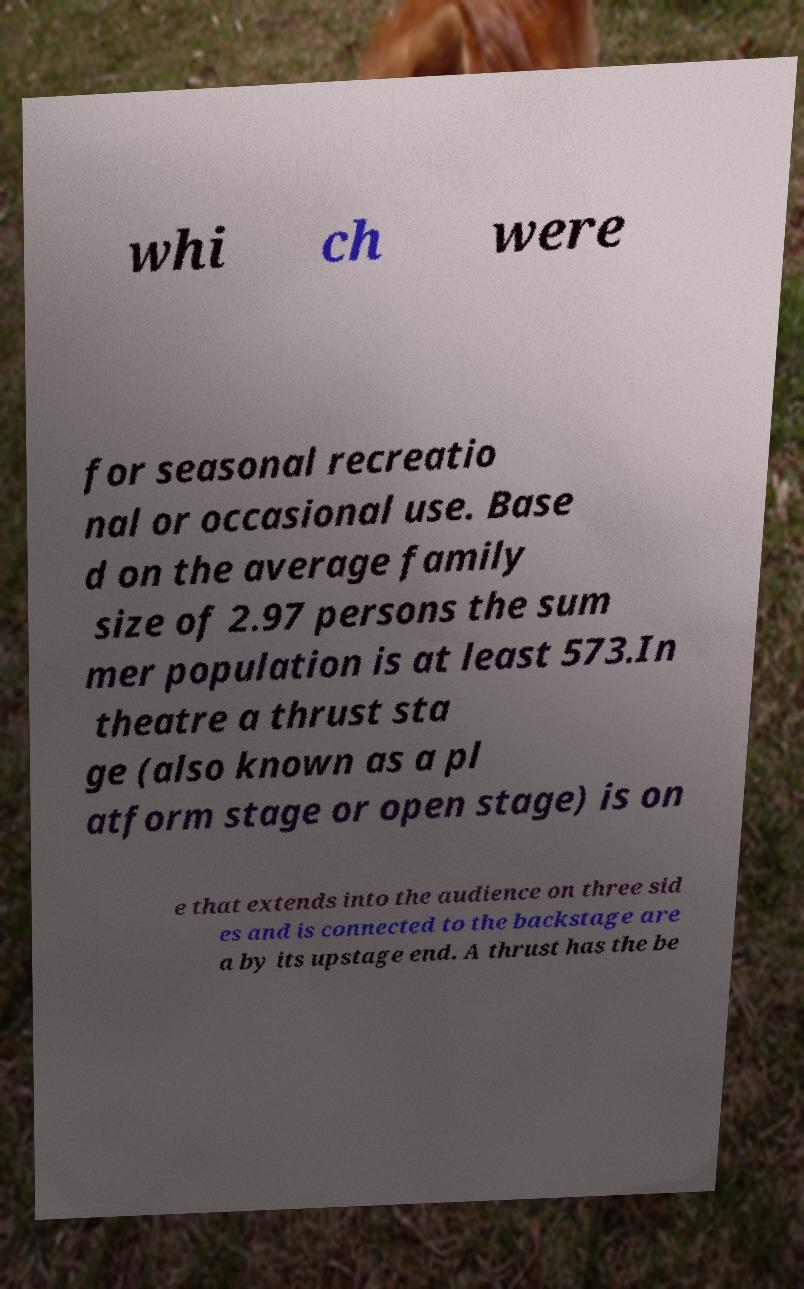Could you assist in decoding the text presented in this image and type it out clearly? whi ch were for seasonal recreatio nal or occasional use. Base d on the average family size of 2.97 persons the sum mer population is at least 573.In theatre a thrust sta ge (also known as a pl atform stage or open stage) is on e that extends into the audience on three sid es and is connected to the backstage are a by its upstage end. A thrust has the be 